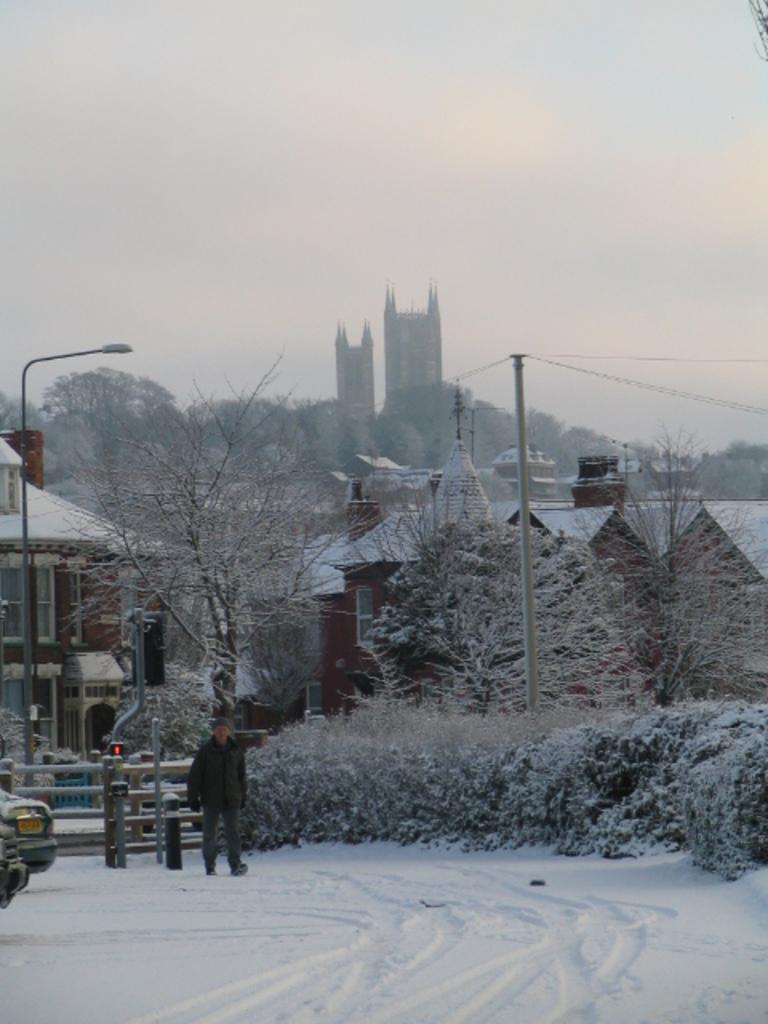Could you give a brief overview of what you see in this image? As we can see in the image there is a man walking, snow, fence, plants, trees, current pole, street lamp, buildings and sky. 